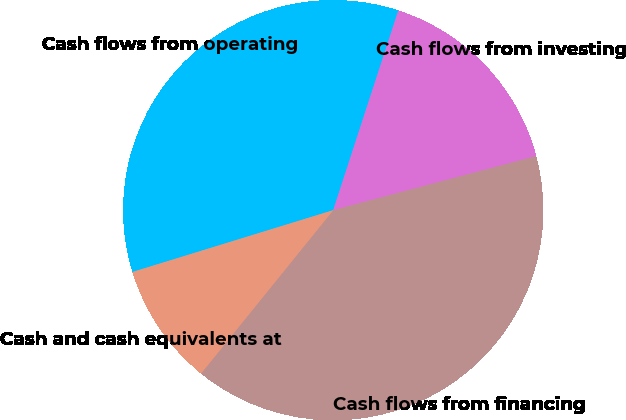<chart> <loc_0><loc_0><loc_500><loc_500><pie_chart><fcel>Cash flows from operating<fcel>Cash flows from investing<fcel>Cash flows from financing<fcel>Cash and cash equivalents at<nl><fcel>34.77%<fcel>15.84%<fcel>39.97%<fcel>9.42%<nl></chart> 